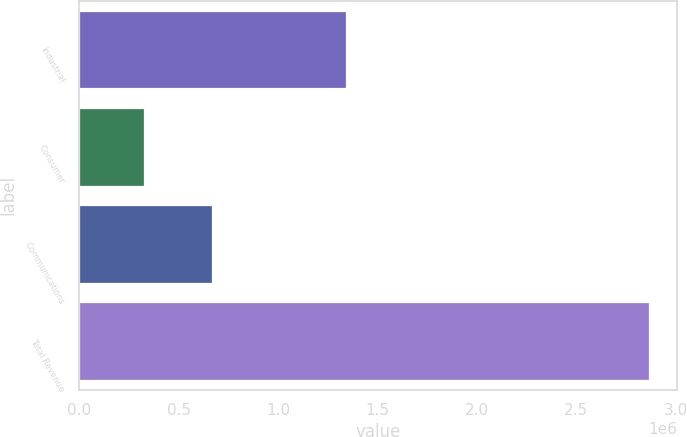Convert chart. <chart><loc_0><loc_0><loc_500><loc_500><bar_chart><fcel>Industrial<fcel>Consumer<fcel>Communications<fcel>Total Revenue<nl><fcel>1.34326e+06<fcel>327223<fcel>668583<fcel>2.86477e+06<nl></chart> 